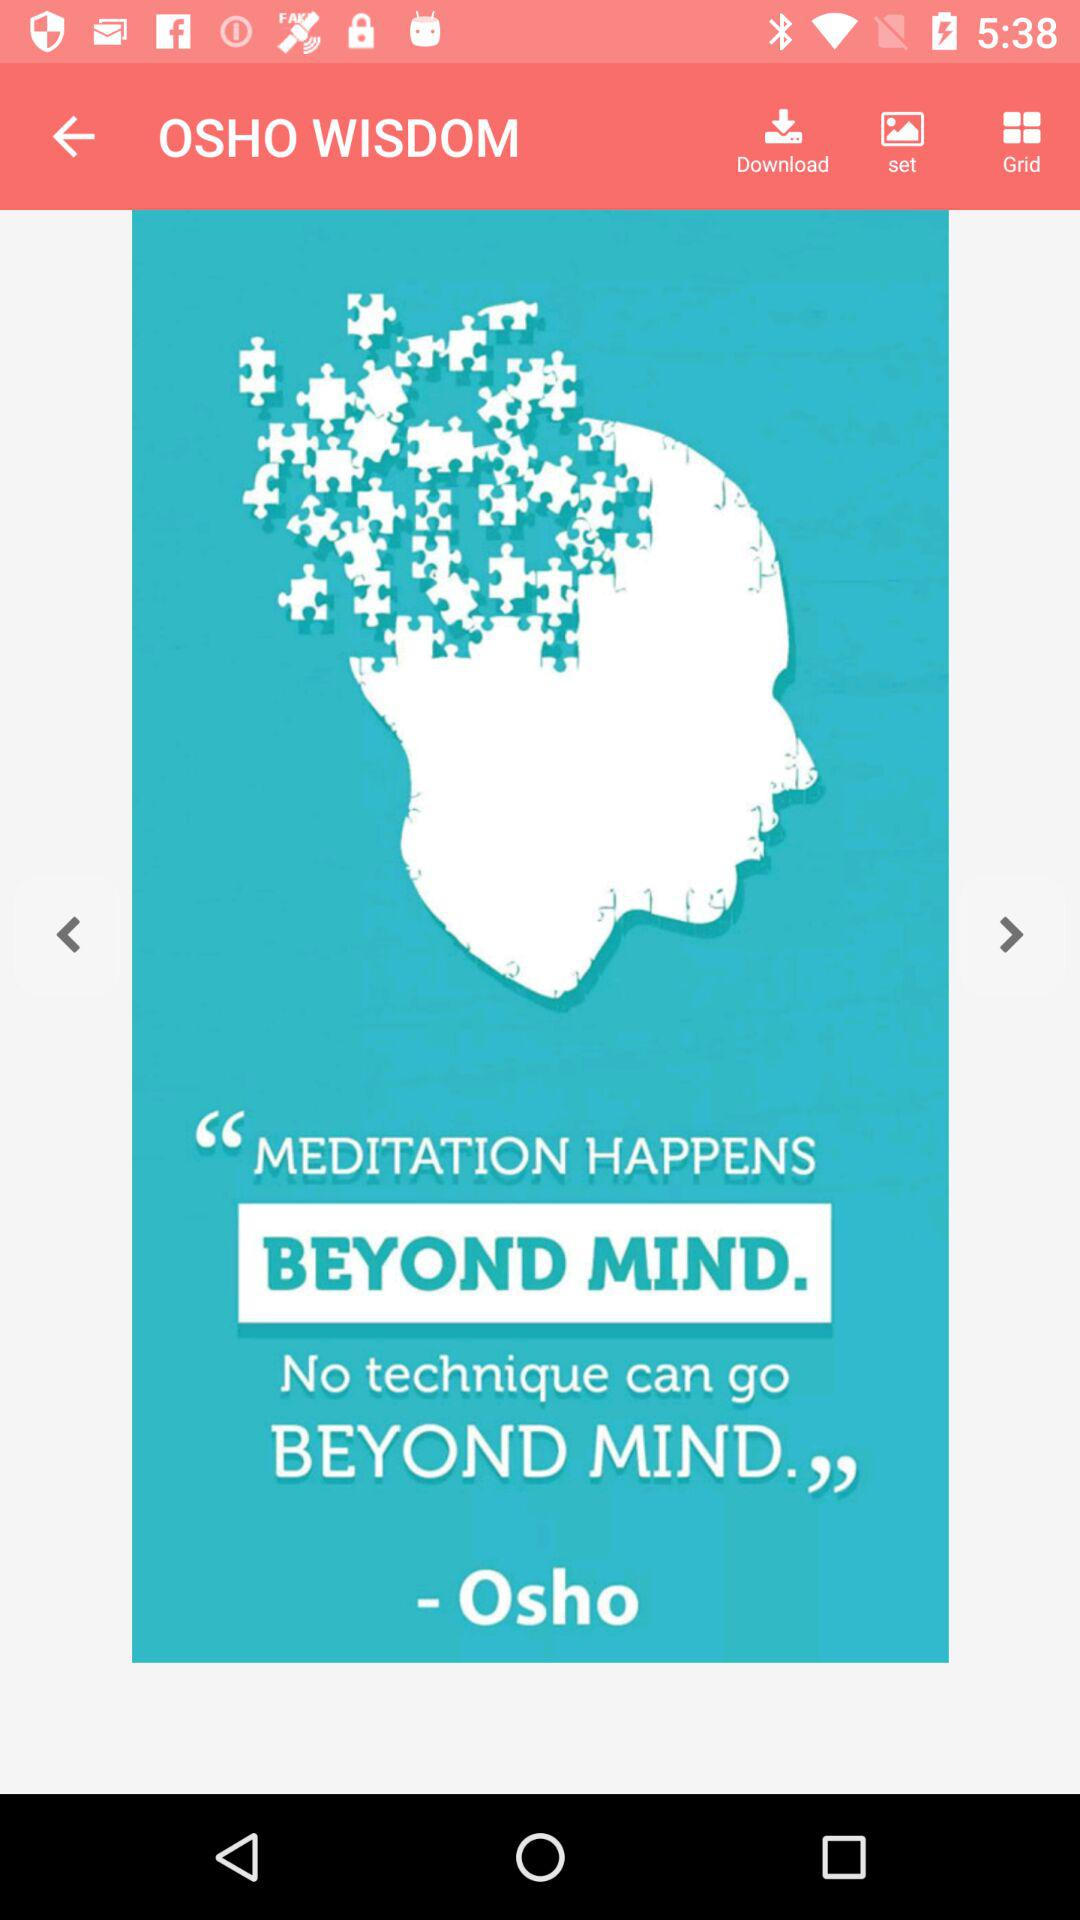What is the application name? The application name is "OSHO WISDOM". 